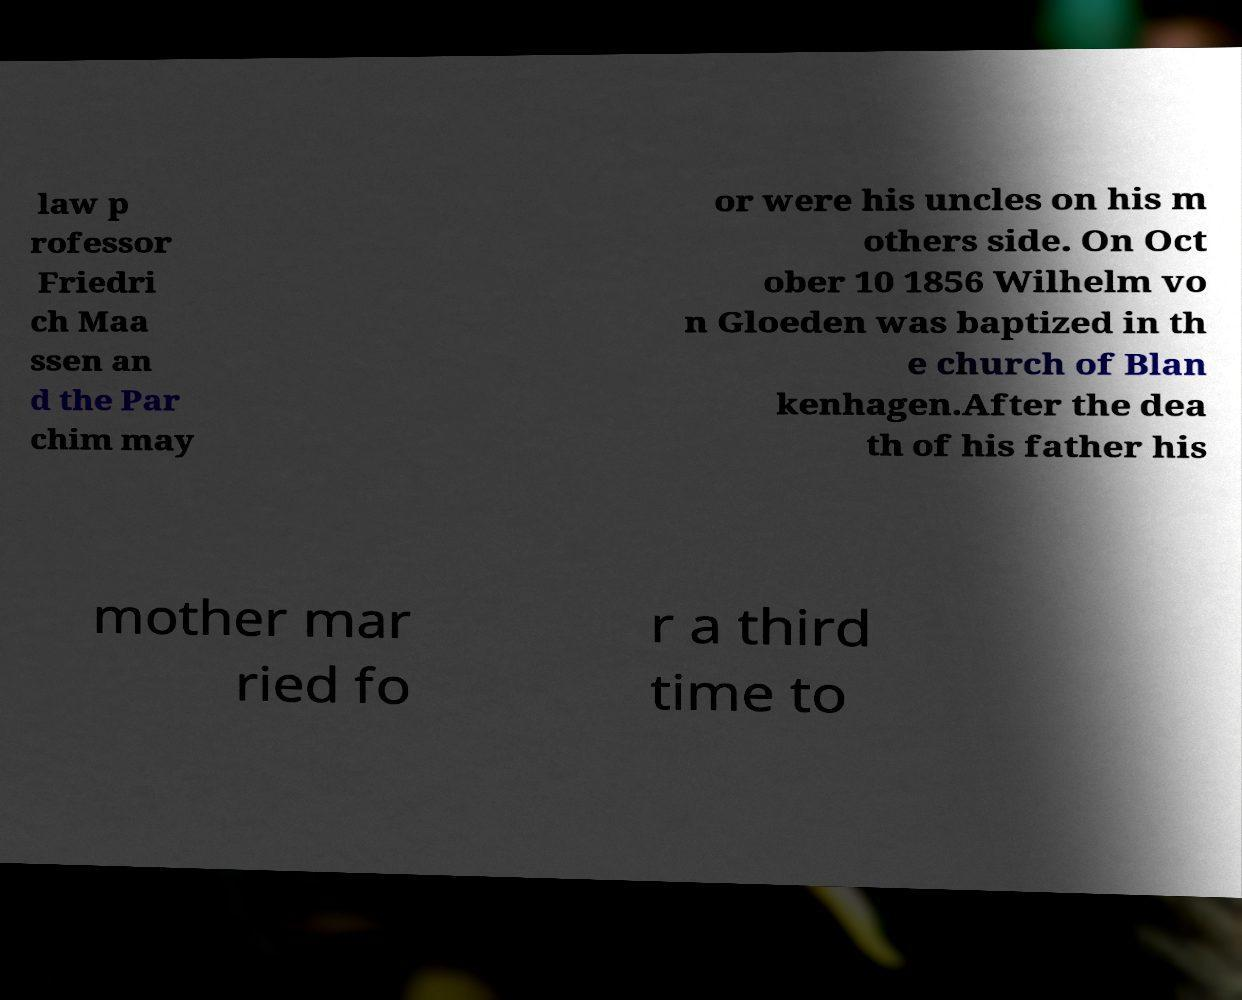For documentation purposes, I need the text within this image transcribed. Could you provide that? law p rofessor Friedri ch Maa ssen an d the Par chim may or were his uncles on his m others side. On Oct ober 10 1856 Wilhelm vo n Gloeden was baptized in th e church of Blan kenhagen.After the dea th of his father his mother mar ried fo r a third time to 